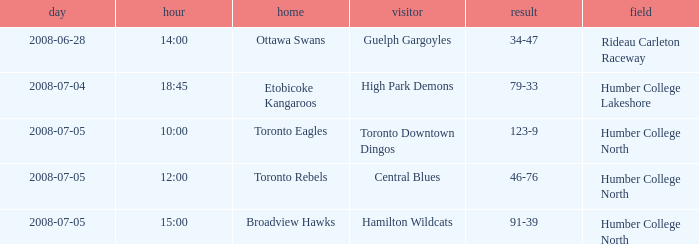What is the Ground with an Away that is central blues? Humber College North. 